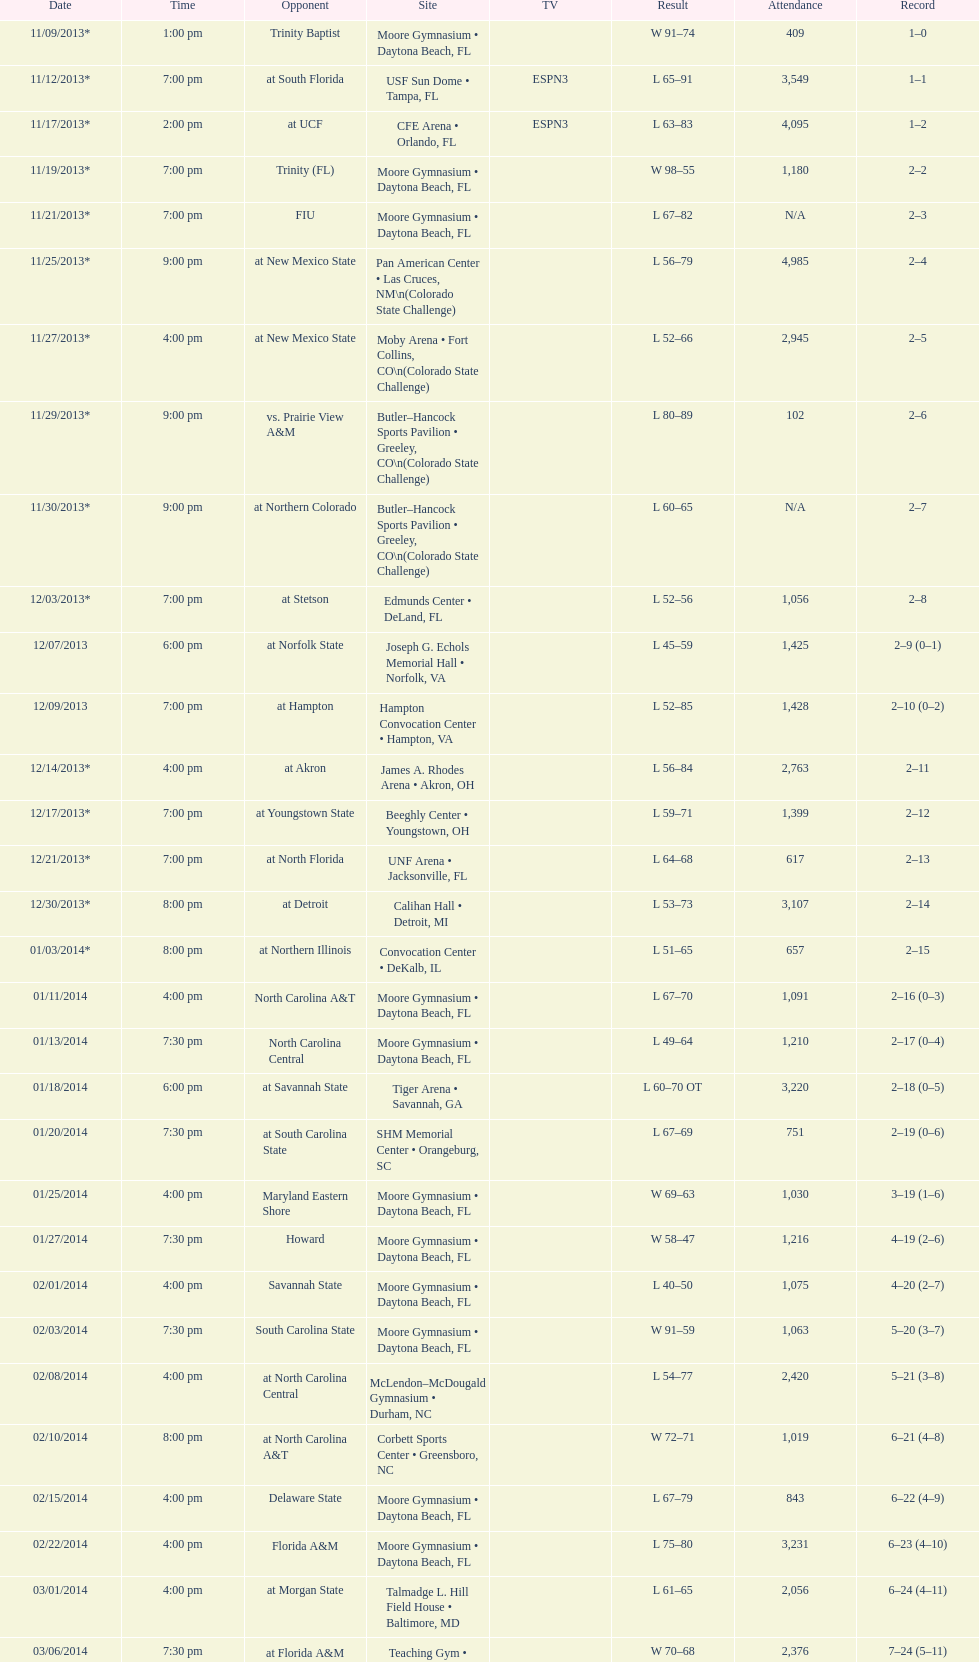How many times did the wildcats compete in games at daytona beach, florida? 11. 